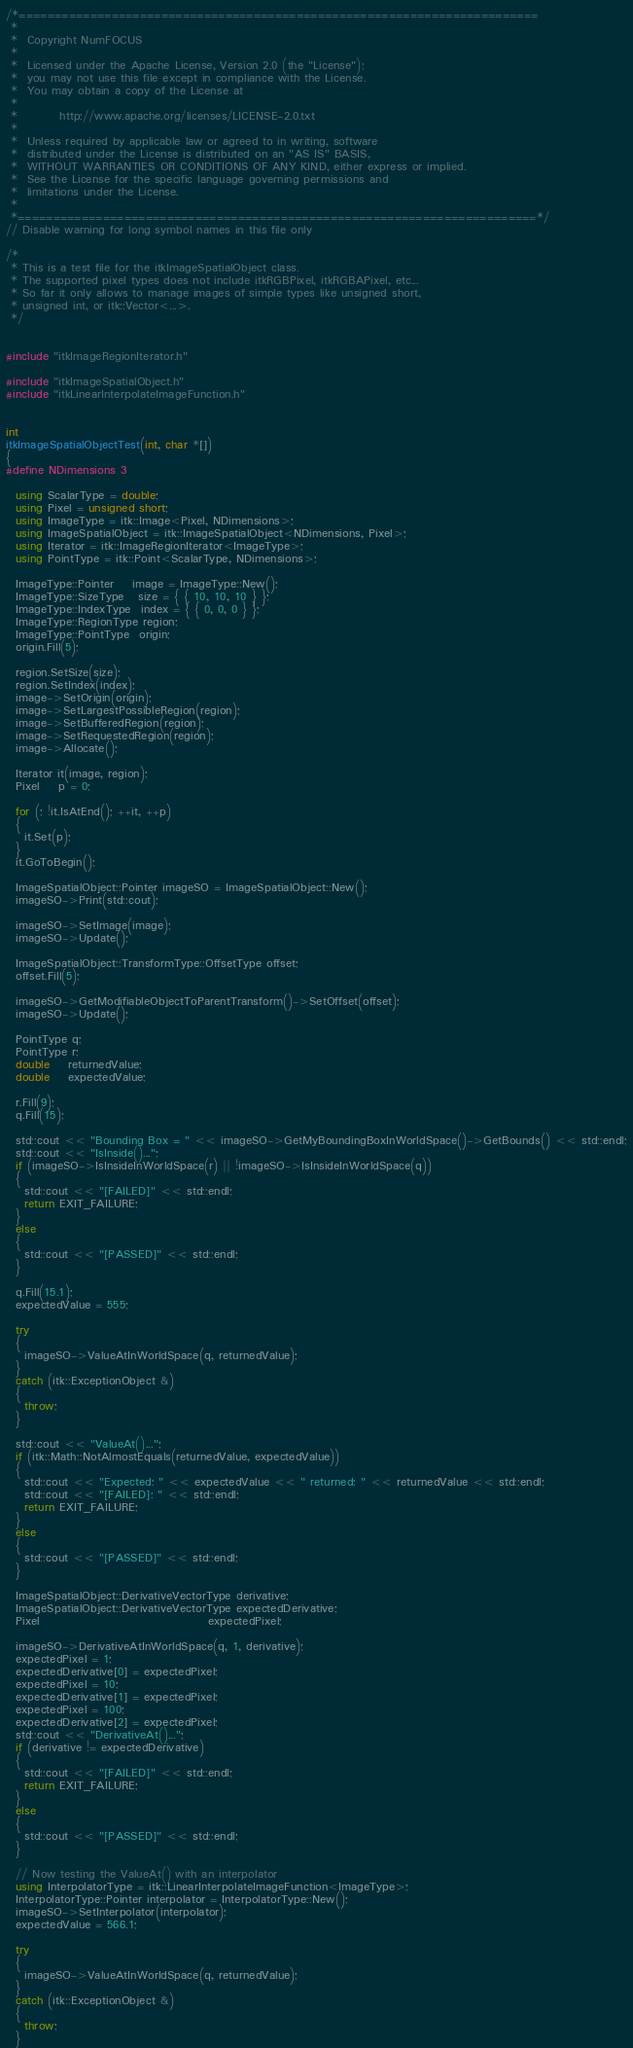<code> <loc_0><loc_0><loc_500><loc_500><_C++_>/*=========================================================================
 *
 *  Copyright NumFOCUS
 *
 *  Licensed under the Apache License, Version 2.0 (the "License");
 *  you may not use this file except in compliance with the License.
 *  You may obtain a copy of the License at
 *
 *         http://www.apache.org/licenses/LICENSE-2.0.txt
 *
 *  Unless required by applicable law or agreed to in writing, software
 *  distributed under the License is distributed on an "AS IS" BASIS,
 *  WITHOUT WARRANTIES OR CONDITIONS OF ANY KIND, either express or implied.
 *  See the License for the specific language governing permissions and
 *  limitations under the License.
 *
 *=========================================================================*/
// Disable warning for long symbol names in this file only

/*
 * This is a test file for the itkImageSpatialObject class.
 * The supported pixel types does not include itkRGBPixel, itkRGBAPixel, etc...
 * So far it only allows to manage images of simple types like unsigned short,
 * unsigned int, or itk::Vector<...>.
 */


#include "itkImageRegionIterator.h"

#include "itkImageSpatialObject.h"
#include "itkLinearInterpolateImageFunction.h"


int
itkImageSpatialObjectTest(int, char *[])
{
#define NDimensions 3

  using ScalarType = double;
  using Pixel = unsigned short;
  using ImageType = itk::Image<Pixel, NDimensions>;
  using ImageSpatialObject = itk::ImageSpatialObject<NDimensions, Pixel>;
  using Iterator = itk::ImageRegionIterator<ImageType>;
  using PointType = itk::Point<ScalarType, NDimensions>;

  ImageType::Pointer    image = ImageType::New();
  ImageType::SizeType   size = { { 10, 10, 10 } };
  ImageType::IndexType  index = { { 0, 0, 0 } };
  ImageType::RegionType region;
  ImageType::PointType  origin;
  origin.Fill(5);

  region.SetSize(size);
  region.SetIndex(index);
  image->SetOrigin(origin);
  image->SetLargestPossibleRegion(region);
  image->SetBufferedRegion(region);
  image->SetRequestedRegion(region);
  image->Allocate();

  Iterator it(image, region);
  Pixel    p = 0;

  for (; !it.IsAtEnd(); ++it, ++p)
  {
    it.Set(p);
  }
  it.GoToBegin();

  ImageSpatialObject::Pointer imageSO = ImageSpatialObject::New();
  imageSO->Print(std::cout);

  imageSO->SetImage(image);
  imageSO->Update();

  ImageSpatialObject::TransformType::OffsetType offset;
  offset.Fill(5);

  imageSO->GetModifiableObjectToParentTransform()->SetOffset(offset);
  imageSO->Update();

  PointType q;
  PointType r;
  double    returnedValue;
  double    expectedValue;

  r.Fill(9);
  q.Fill(15);

  std::cout << "Bounding Box = " << imageSO->GetMyBoundingBoxInWorldSpace()->GetBounds() << std::endl;
  std::cout << "IsInside()...";
  if (imageSO->IsInsideInWorldSpace(r) || !imageSO->IsInsideInWorldSpace(q))
  {
    std::cout << "[FAILED]" << std::endl;
    return EXIT_FAILURE;
  }
  else
  {
    std::cout << "[PASSED]" << std::endl;
  }

  q.Fill(15.1);
  expectedValue = 555;

  try
  {
    imageSO->ValueAtInWorldSpace(q, returnedValue);
  }
  catch (itk::ExceptionObject &)
  {
    throw;
  }

  std::cout << "ValueAt()...";
  if (itk::Math::NotAlmostEquals(returnedValue, expectedValue))
  {
    std::cout << "Expected: " << expectedValue << " returned: " << returnedValue << std::endl;
    std::cout << "[FAILED]: " << std::endl;
    return EXIT_FAILURE;
  }
  else
  {
    std::cout << "[PASSED]" << std::endl;
  }

  ImageSpatialObject::DerivativeVectorType derivative;
  ImageSpatialObject::DerivativeVectorType expectedDerivative;
  Pixel                                    expectedPixel;

  imageSO->DerivativeAtInWorldSpace(q, 1, derivative);
  expectedPixel = 1;
  expectedDerivative[0] = expectedPixel;
  expectedPixel = 10;
  expectedDerivative[1] = expectedPixel;
  expectedPixel = 100;
  expectedDerivative[2] = expectedPixel;
  std::cout << "DerivativeAt()...";
  if (derivative != expectedDerivative)
  {
    std::cout << "[FAILED]" << std::endl;
    return EXIT_FAILURE;
  }
  else
  {
    std::cout << "[PASSED]" << std::endl;
  }

  // Now testing the ValueAt() with an interpolator
  using InterpolatorType = itk::LinearInterpolateImageFunction<ImageType>;
  InterpolatorType::Pointer interpolator = InterpolatorType::New();
  imageSO->SetInterpolator(interpolator);
  expectedValue = 566.1;

  try
  {
    imageSO->ValueAtInWorldSpace(q, returnedValue);
  }
  catch (itk::ExceptionObject &)
  {
    throw;
  }
</code> 